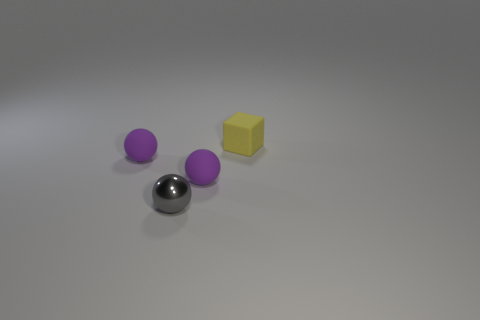Does the small block have the same color as the shiny object?
Provide a short and direct response. No. What is the size of the purple sphere that is on the right side of the metal ball?
Give a very brief answer. Small. Is there a purple sphere that has the same size as the gray shiny thing?
Keep it short and to the point. Yes. Do the purple thing that is left of the gray ball and the matte cube have the same size?
Offer a terse response. Yes. What is the size of the metallic object?
Offer a terse response. Small. There is a rubber thing in front of the rubber ball on the left side of the ball that is right of the gray metal thing; what is its color?
Make the answer very short. Purple. There is a object left of the small gray sphere; is it the same color as the metallic thing?
Offer a terse response. No. How many small objects are in front of the small yellow object and behind the gray shiny object?
Ensure brevity in your answer.  2. There is a yellow matte thing that is behind the small purple thing on the left side of the gray metal thing; how many yellow rubber things are in front of it?
Provide a succinct answer. 0. There is a rubber object that is in front of the purple sphere left of the tiny gray metal thing; what is its color?
Offer a terse response. Purple. 